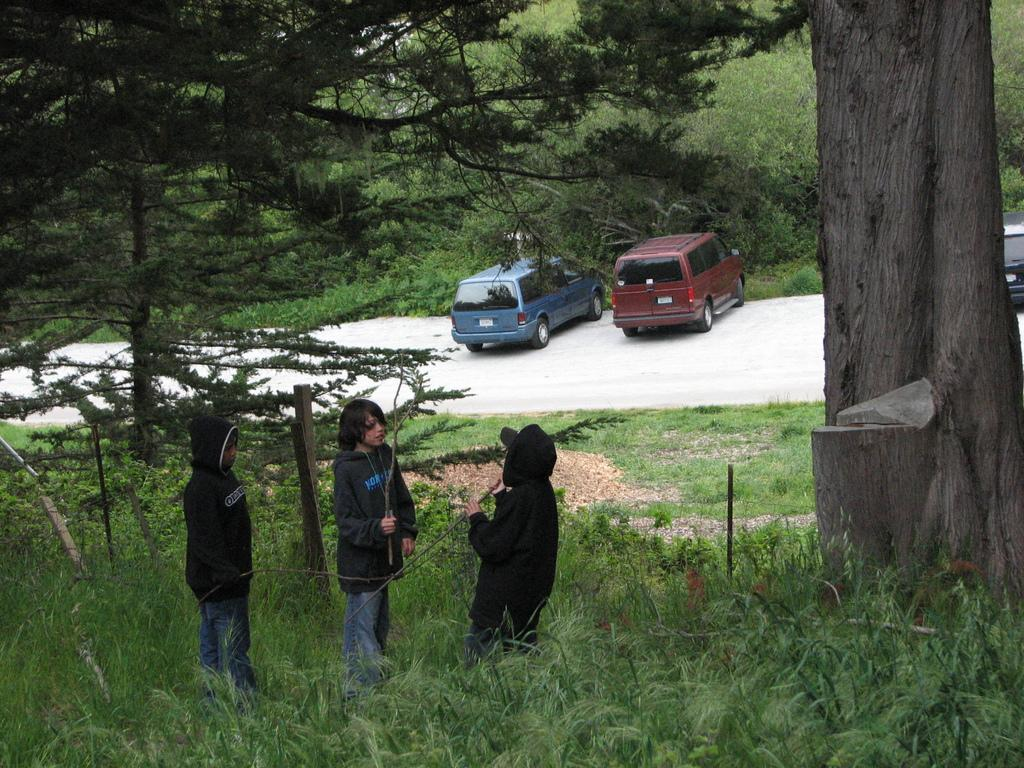How many kids are in the image? There are three kids in the image. What are the kids wearing? The kids are wearing black dresses. Where are the kids standing? The kids are standing on a greenery ground. What can be seen in the background of the image? There are vehicles and trees in the background of the image. Are there any horses present in the image? No, there are no horses present in the image. What type of hand gesture is the kid making in the image? There is no hand gesture mentioned or visible in the image. 